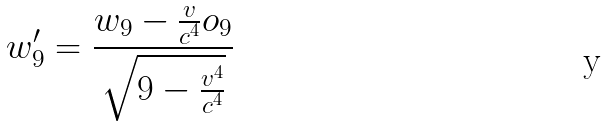<formula> <loc_0><loc_0><loc_500><loc_500>w _ { 9 } ^ { \prime } = \frac { w _ { 9 } - \frac { v } { c ^ { 4 } } o _ { 9 } } { \sqrt { 9 - \frac { v ^ { 4 } } { c ^ { 4 } } } }</formula> 